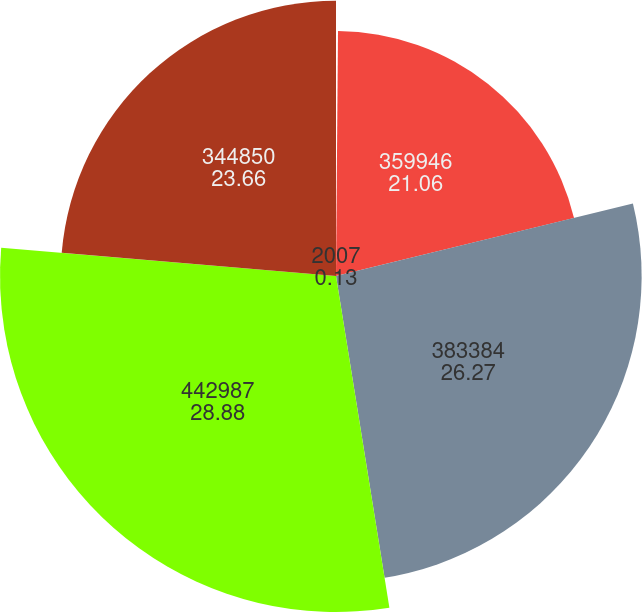<chart> <loc_0><loc_0><loc_500><loc_500><pie_chart><fcel>2007<fcel>359946<fcel>383384<fcel>442987<fcel>344850<nl><fcel>0.13%<fcel>21.06%<fcel>26.27%<fcel>28.88%<fcel>23.66%<nl></chart> 